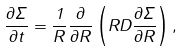Convert formula to latex. <formula><loc_0><loc_0><loc_500><loc_500>\frac { \partial \Sigma } { \partial t } = \frac { 1 } { R } \frac { \partial } { \partial R } \left ( R D \frac { \partial \Sigma } { \partial R } \right ) ,</formula> 